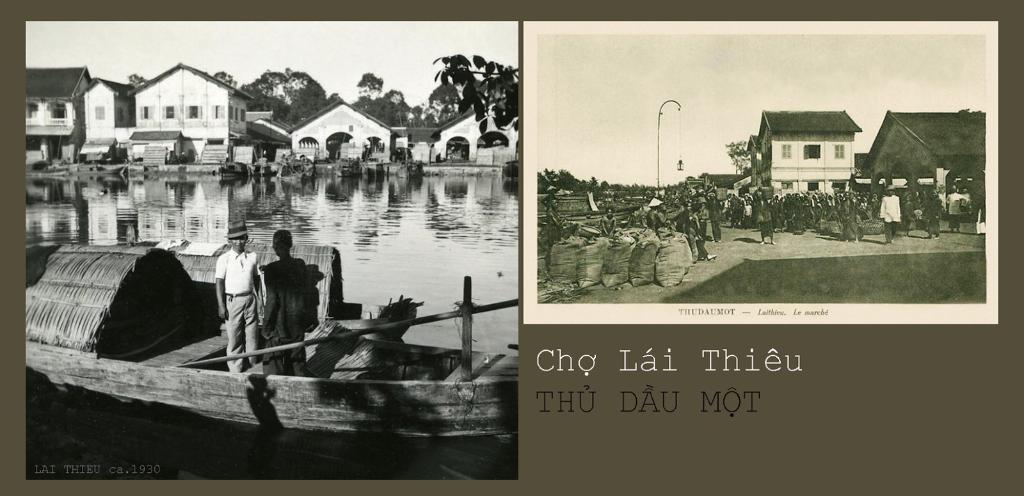Describe this image in one or two sentences. This image is a collage. In the first image there is water and we can see a boat on the water. There are people standing in the boat. In the background there are sheds, trees and sky. In the second image we can see gunny bags and there are people. In the background there are sheds, trees and sky. There is a pole and we can see text. 